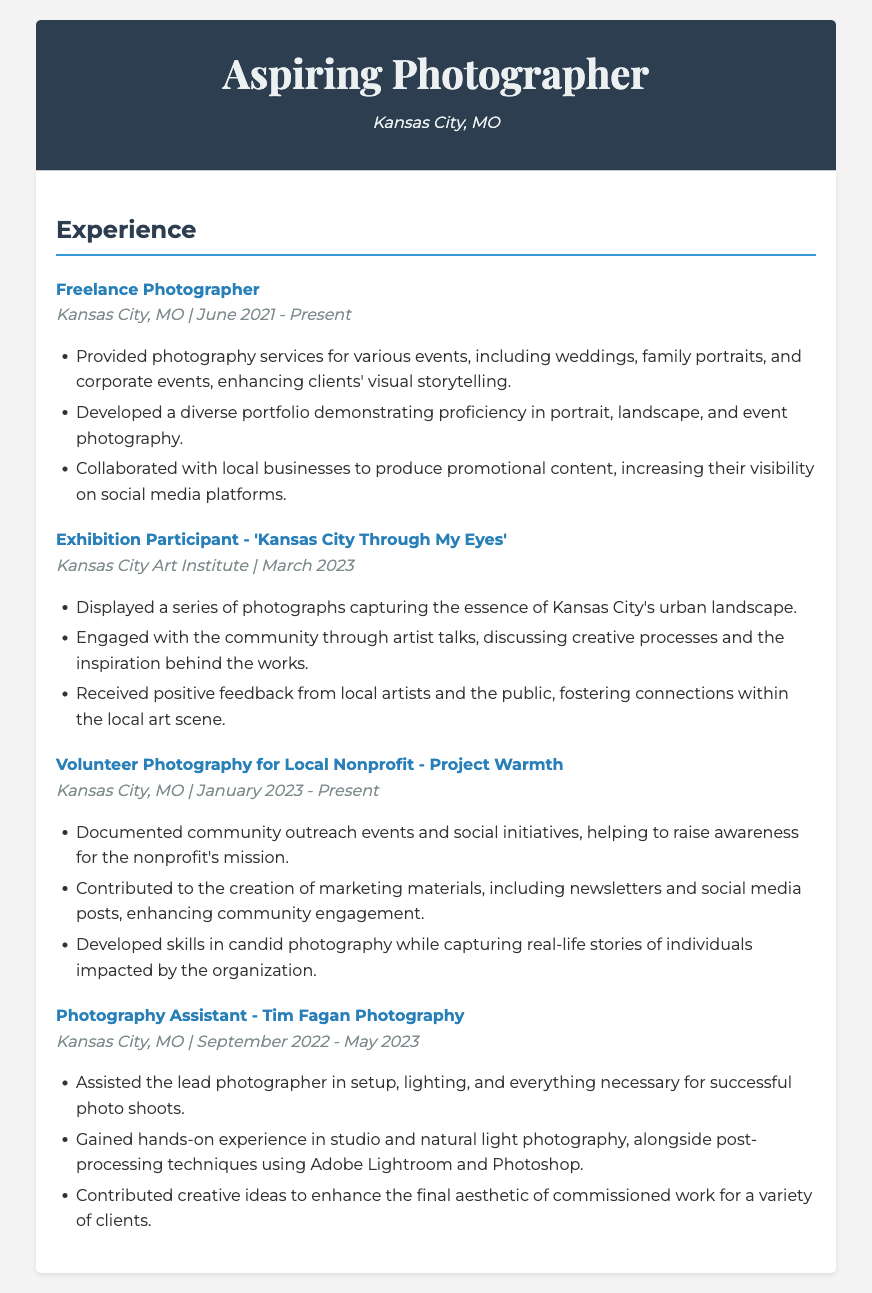What is the title of the freelance photography gig? The title of the freelance photography gig is clearly stated in the document as "Freelance Photographer."
Answer: Freelance Photographer When did the exhibition 'Kansas City Through My Eyes' take place? The date of the exhibition is mentioned as March 2023 in the document.
Answer: March 2023 Which local nonprofit did the subject volunteer for? The nonprofit organization is specified as "Project Warmth" in the document.
Answer: Project Warmth What was one of the photography skills developed through the volunteer project? The document states that skills in candid photography were developed during the volunteer project.
Answer: Candid photography Who did the subject assist at the photography assistant role? The document mentions that the subject assisted "Tim Fagan Photography" as a photography assistant.
Answer: Tim Fagan Photography What type of events did the freelance photographer provide services for? The document lists types of events like weddings, family portraits, and corporate events as services provided.
Answer: Weddings, family portraits, and corporate events How long did the subject work as a photography assistant? The duration is listed as September 2022 to May 2023, which is approximately 8 months.
Answer: 8 months What kind of community engagement activities did the subject participate in during the exhibition? The document notes that the subject engaged through artist talks during the exhibition activities.
Answer: Artist talks What is the location of the exhibition? The location of the exhibition is provided as "Kansas City Art Institute" in the document.
Answer: Kansas City Art Institute 